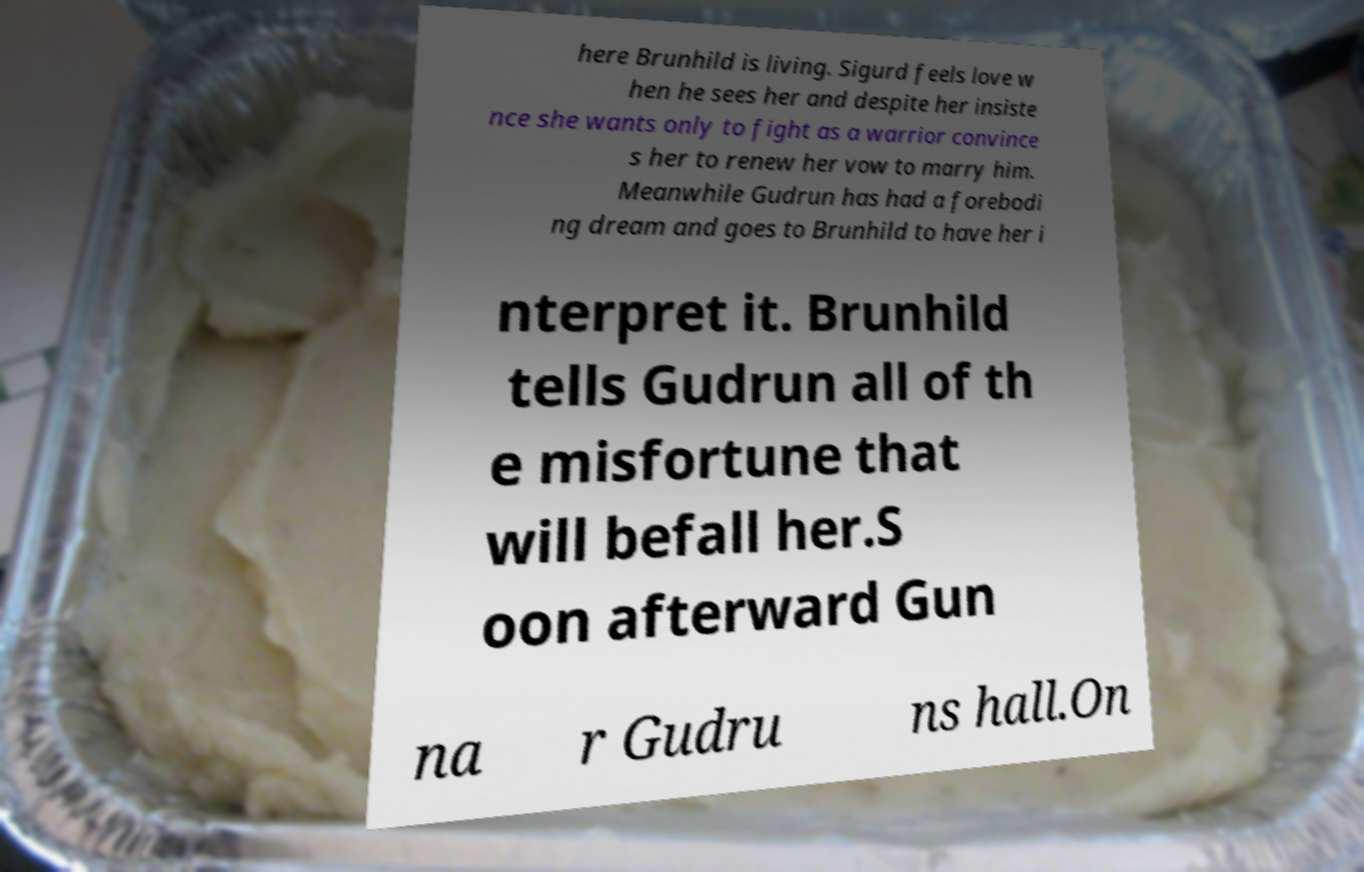Could you extract and type out the text from this image? here Brunhild is living. Sigurd feels love w hen he sees her and despite her insiste nce she wants only to fight as a warrior convince s her to renew her vow to marry him. Meanwhile Gudrun has had a forebodi ng dream and goes to Brunhild to have her i nterpret it. Brunhild tells Gudrun all of th e misfortune that will befall her.S oon afterward Gun na r Gudru ns hall.On 